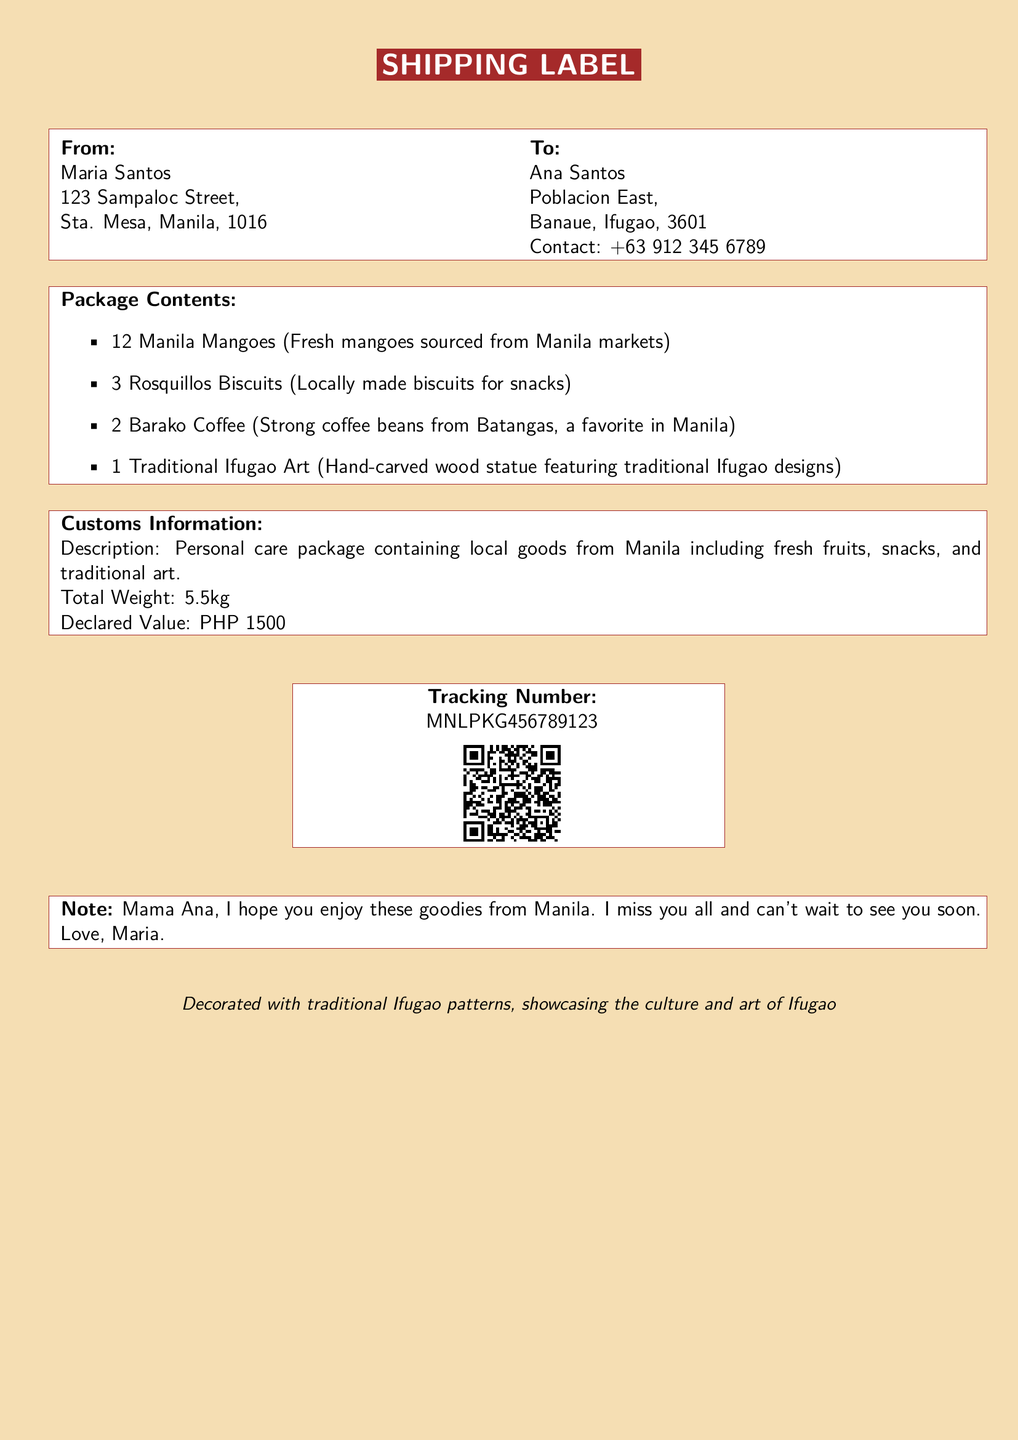What is the sender's name? The sender's name is listed at the top of the document under "From," which states Maria Santos.
Answer: Maria Santos What is the recipient's contact number? The recipient's contact number is mentioned under "To" next to Ana Santos.
Answer: +63 912 345 6789 What type of coffee is included in the package? The type of coffee is specified in the "Package Contents" section as Barako Coffee.
Answer: Barako Coffee What is the total weight of the package? The total weight is provided in the "Customs Information" section.
Answer: 5.5kg What is the tracking number? The tracking number is displayed prominently on the label for shipment reference.
Answer: MNLPKG456789123 How many mangoes are included in the package? The number of mangoes is specified in the "Package Contents" as 12 Manila Mangoes.
Answer: 12 What is the declared value of the package? The declared value is included in the "Customs Information" section of the document.
Answer: PHP 1500 What is the primary purpose of this shipping label? The purpose can be inferred from the details provided about sending a care package.
Answer: Care package What message does the sender include for the recipient? The note from the sender is included at the end of the label, expressing affection.
Answer: Mama Ana, I hope you enjoy these goodies from Manila. I miss you all and can't wait to see you soon. Love, Maria 